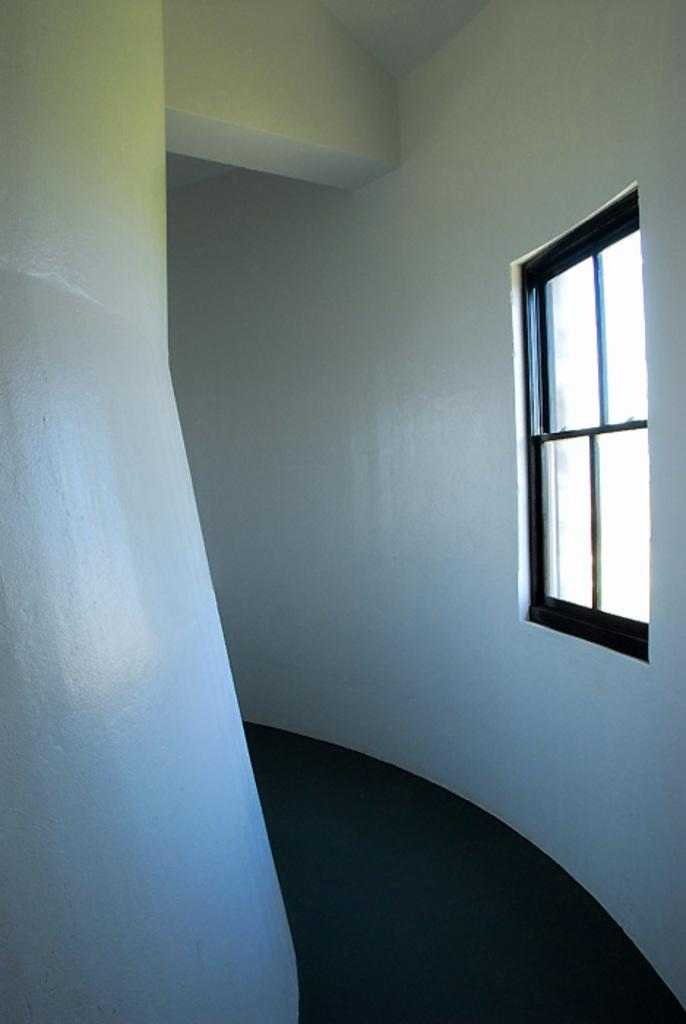Where was the image taken? The image was taken in a room. What can be seen on the right side of the image? There is a window on the right side of the image. What is visible in the background of the image? There is a wall visible in the background of the image. What type of cushion is being licked by the pet in the image? There is no pet or cushion present in the image. What color is the pet's tongue in the image? There is no pet or tongue present in the image. 